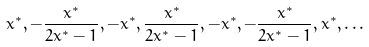Convert formula to latex. <formula><loc_0><loc_0><loc_500><loc_500>x ^ { * } , - \frac { x ^ { * } } { 2 x ^ { * } - 1 } , - x ^ { * } , \frac { x ^ { * } } { 2 x ^ { * } - 1 } , - x ^ { * } , - \frac { x ^ { * } } { 2 x ^ { * } - 1 } , x ^ { * } , \dots</formula> 